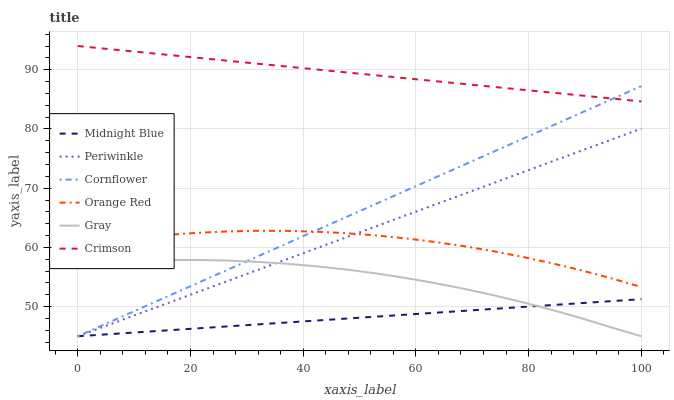Does Midnight Blue have the minimum area under the curve?
Answer yes or no. Yes. Does Crimson have the maximum area under the curve?
Answer yes or no. Yes. Does Gray have the minimum area under the curve?
Answer yes or no. No. Does Gray have the maximum area under the curve?
Answer yes or no. No. Is Periwinkle the smoothest?
Answer yes or no. Yes. Is Orange Red the roughest?
Answer yes or no. Yes. Is Midnight Blue the smoothest?
Answer yes or no. No. Is Midnight Blue the roughest?
Answer yes or no. No. Does Cornflower have the lowest value?
Answer yes or no. Yes. Does Crimson have the lowest value?
Answer yes or no. No. Does Crimson have the highest value?
Answer yes or no. Yes. Does Gray have the highest value?
Answer yes or no. No. Is Gray less than Crimson?
Answer yes or no. Yes. Is Crimson greater than Periwinkle?
Answer yes or no. Yes. Does Orange Red intersect Cornflower?
Answer yes or no. Yes. Is Orange Red less than Cornflower?
Answer yes or no. No. Is Orange Red greater than Cornflower?
Answer yes or no. No. Does Gray intersect Crimson?
Answer yes or no. No. 